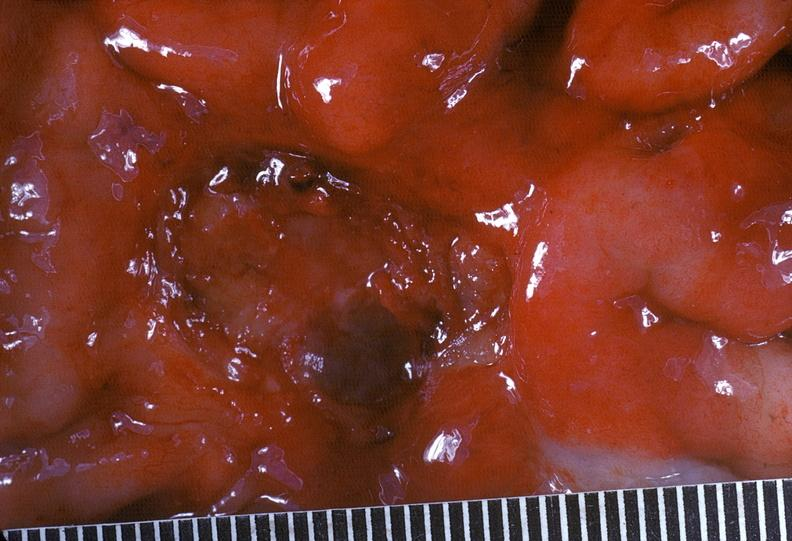where does this belong to?
Answer the question using a single word or phrase. Gastrointestinal system 